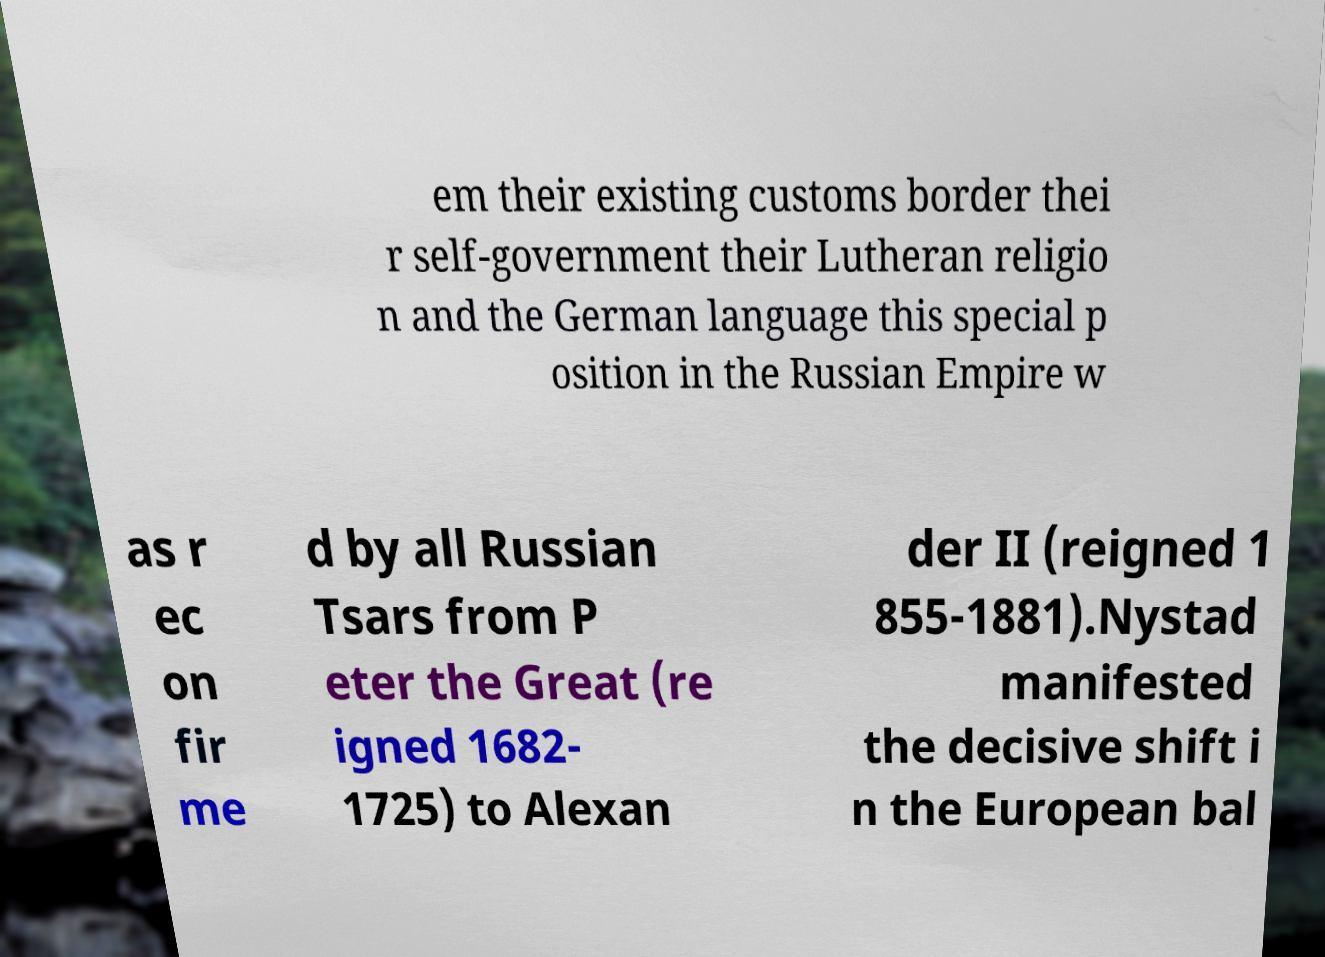What messages or text are displayed in this image? I need them in a readable, typed format. em their existing customs border thei r self-government their Lutheran religio n and the German language this special p osition in the Russian Empire w as r ec on fir me d by all Russian Tsars from P eter the Great (re igned 1682- 1725) to Alexan der II (reigned 1 855-1881).Nystad manifested the decisive shift i n the European bal 